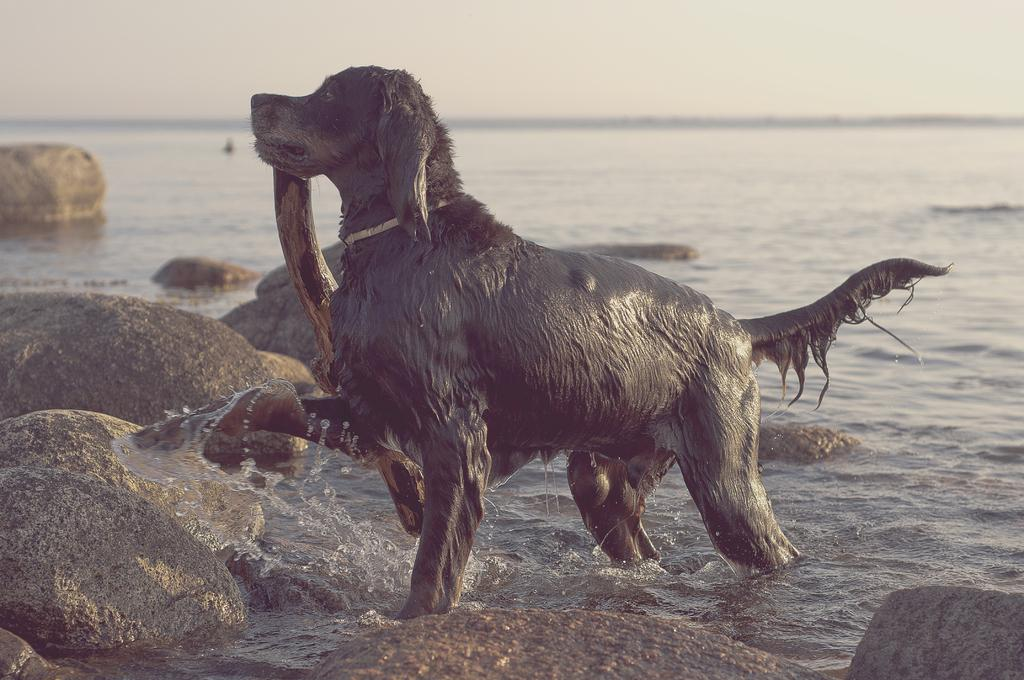What animal can be seen in the image? There is a dog in the image. What is the dog doing in the image? The dog is holding a fish in its mouth. Where is the dog located in the image? The dog is standing in a river. What can be seen on the left side bottom of the image? There are rocks on the left side bottom of the image. What flavor of ice cream does the dog wish to have after catching the fish? There is no mention of ice cream or the dog's wishes in the image, as it features a dog holding a fish in its mouth while standing in a river. 